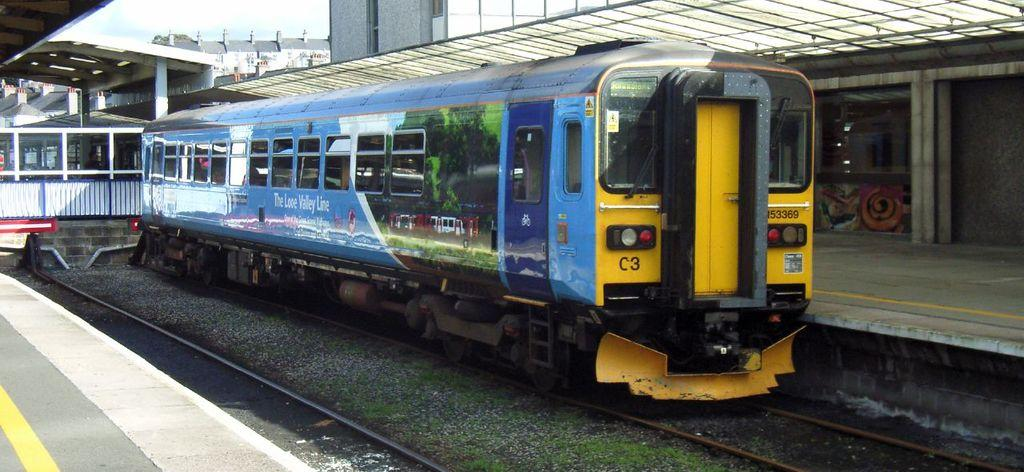What is the main subject of the image? The main subject of the image is a small train. Where is the train located in the image? The train is on a railway track. What is present on either side of the railway track? There are sheltered platforms on either side of the railway track. What type of wax can be seen melting on the train in the image? There is no wax present in the image, and therefore no such activity can be observed. 